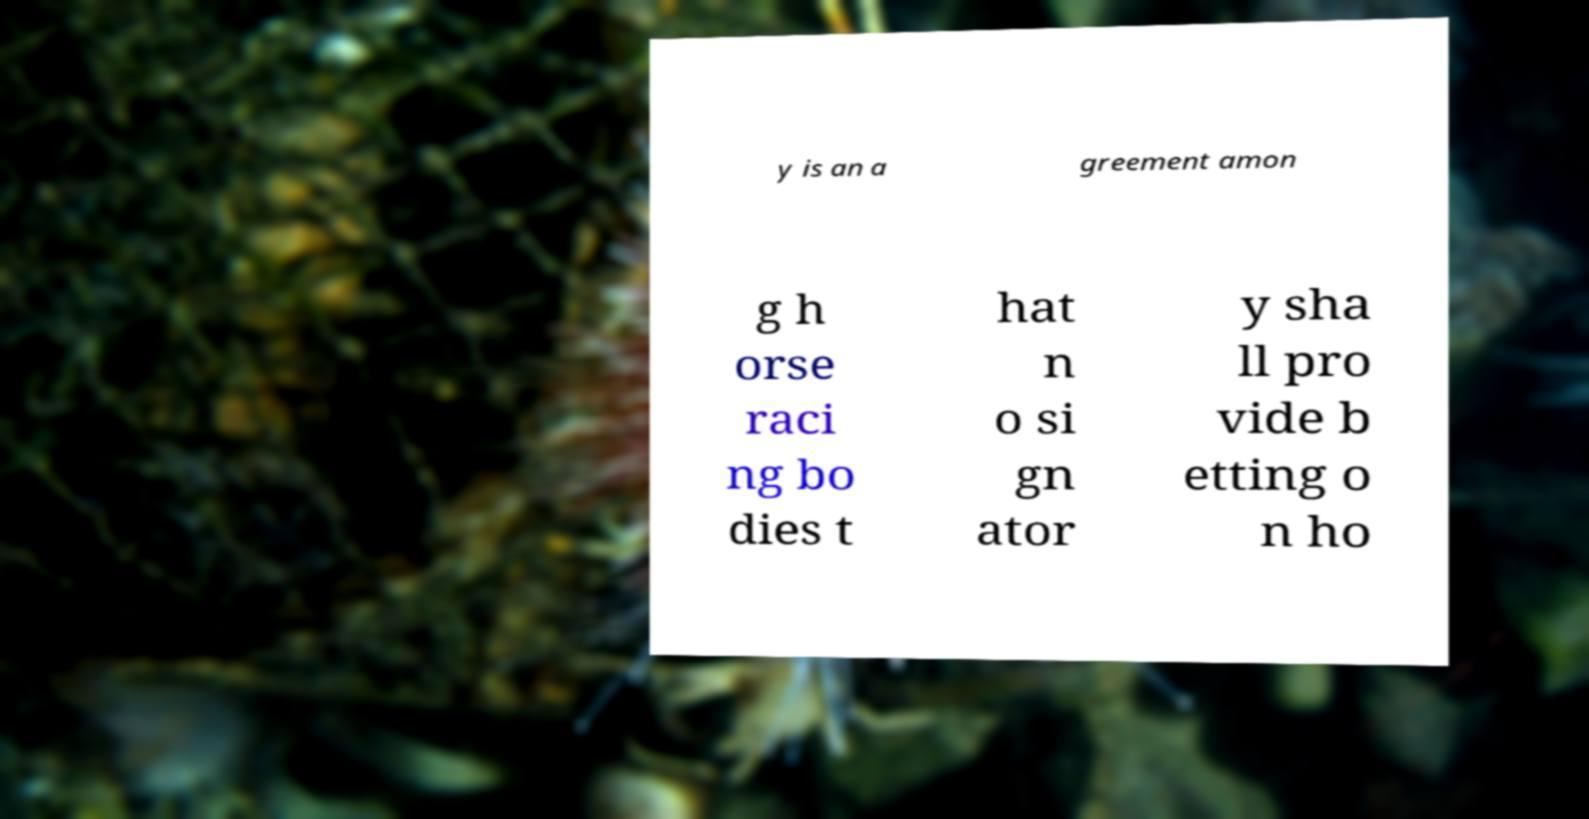Please read and relay the text visible in this image. What does it say? y is an a greement amon g h orse raci ng bo dies t hat n o si gn ator y sha ll pro vide b etting o n ho 